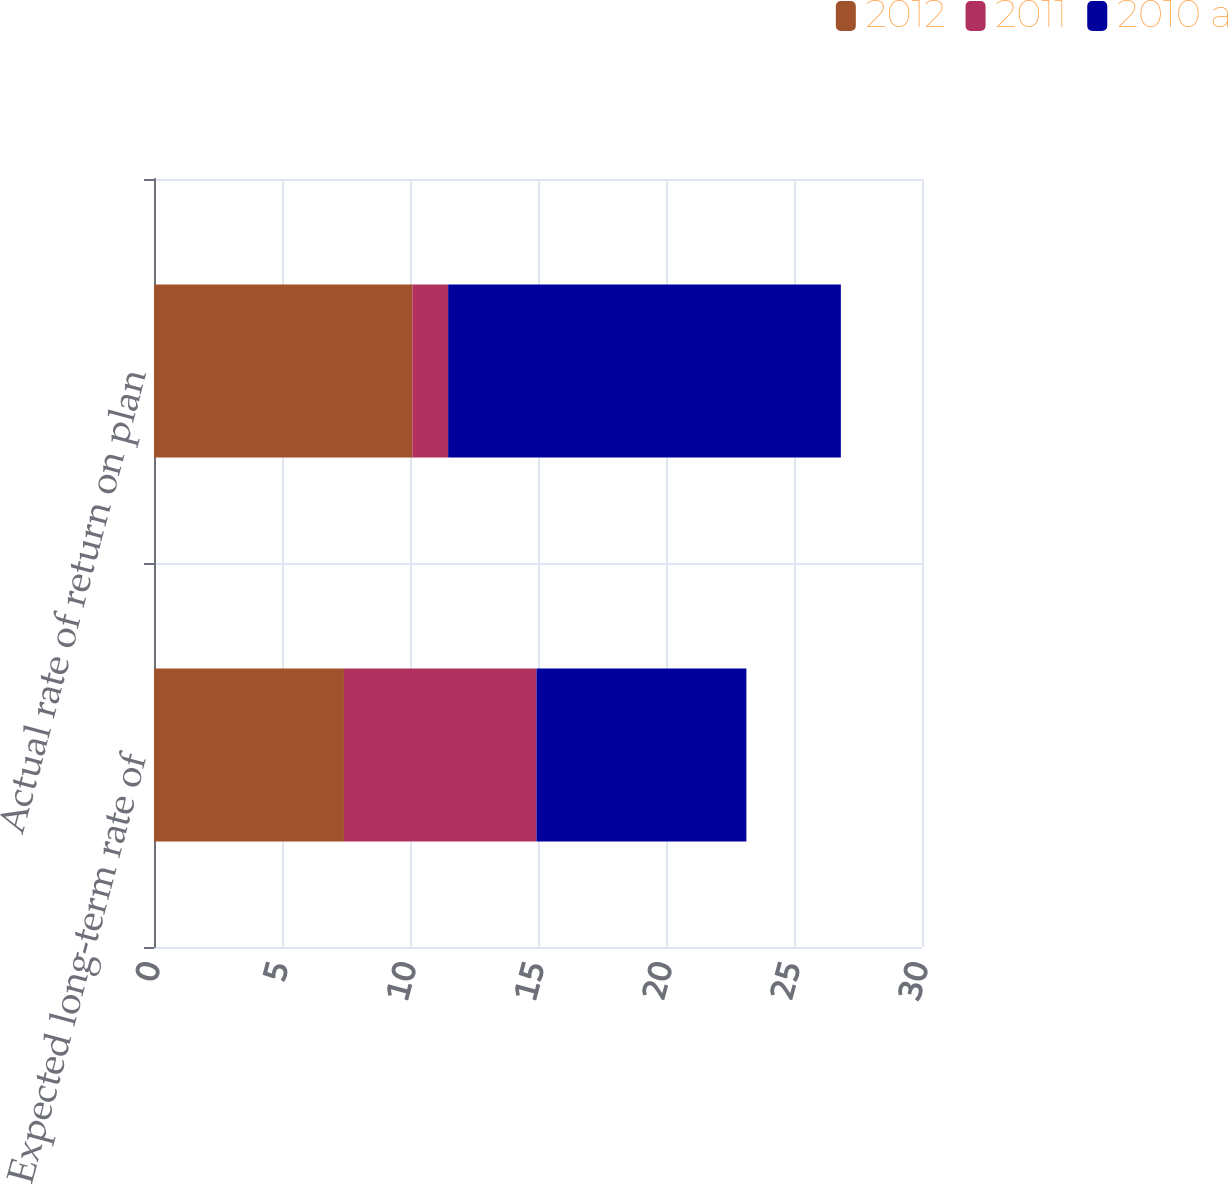<chart> <loc_0><loc_0><loc_500><loc_500><stacked_bar_chart><ecel><fcel>Expected long-term rate of<fcel>Actual rate of return on plan<nl><fcel>2012<fcel>7.42<fcel>10.09<nl><fcel>2011<fcel>7.52<fcel>1.4<nl><fcel>2010 a<fcel>8.2<fcel>15.34<nl></chart> 